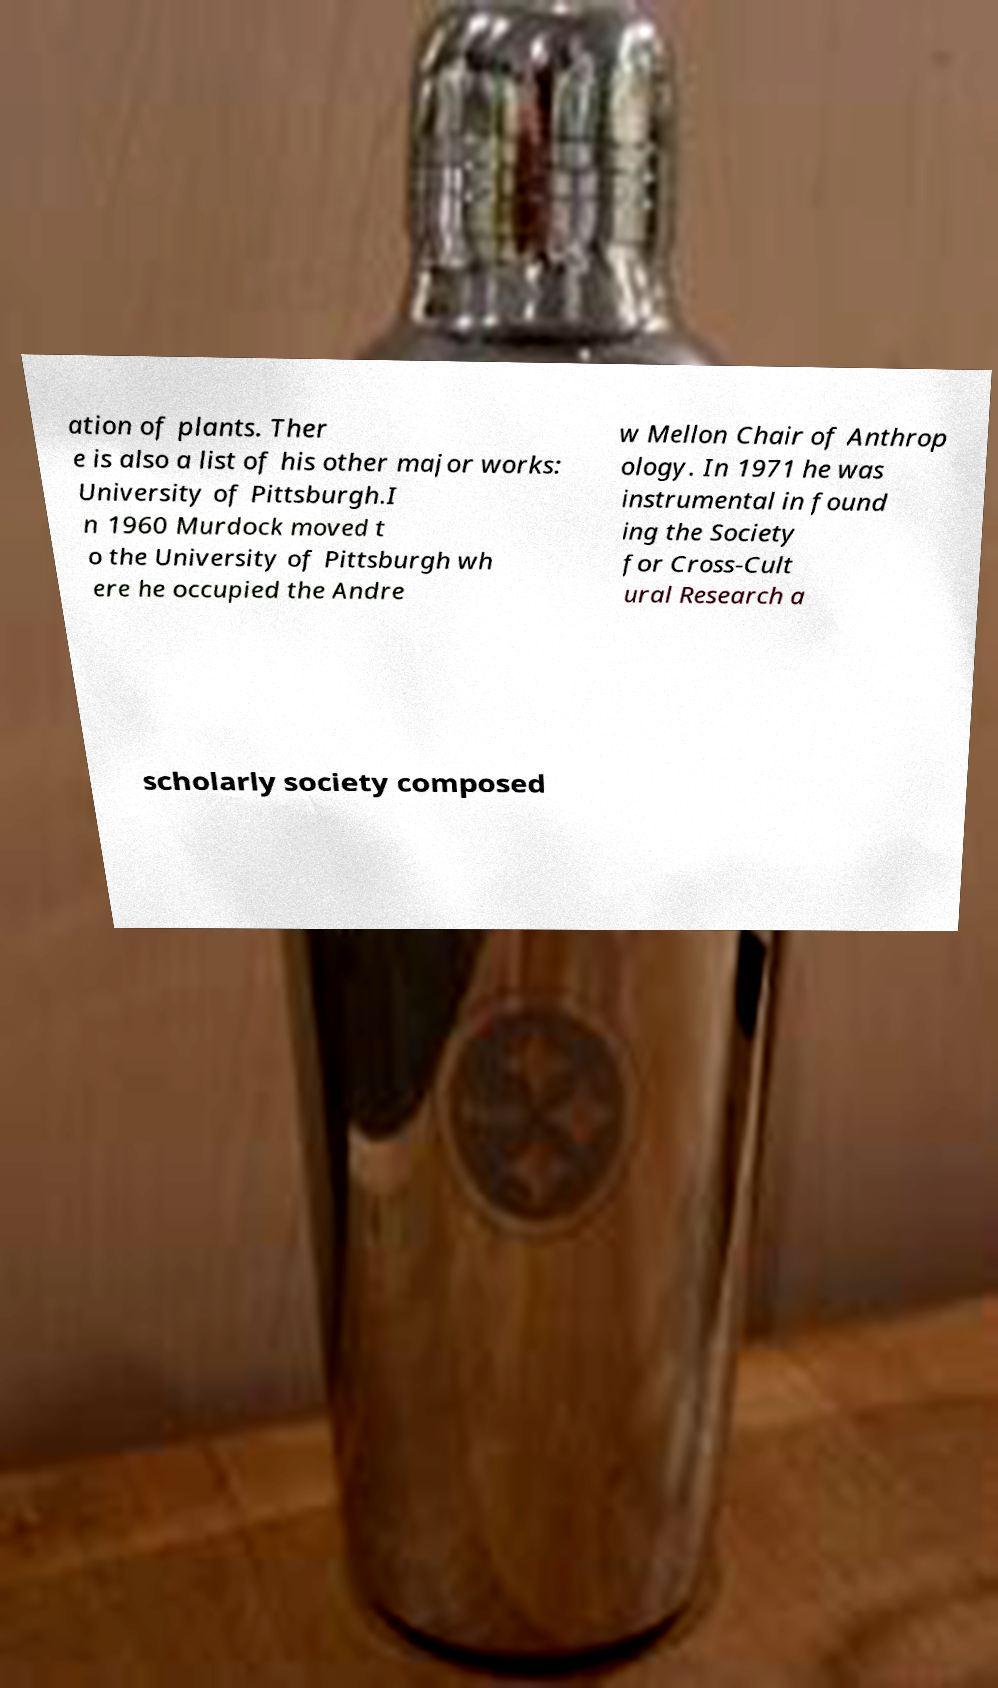There's text embedded in this image that I need extracted. Can you transcribe it verbatim? ation of plants. Ther e is also a list of his other major works: University of Pittsburgh.I n 1960 Murdock moved t o the University of Pittsburgh wh ere he occupied the Andre w Mellon Chair of Anthrop ology. In 1971 he was instrumental in found ing the Society for Cross-Cult ural Research a scholarly society composed 